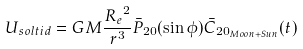<formula> <loc_0><loc_0><loc_500><loc_500>U _ { s o l t i d } = G M \frac { { R _ { e } } ^ { 2 } } { r ^ { 3 } } \bar { P } _ { 2 0 } ( \sin \phi ) \bar { C } _ { { 2 0 } _ { M o o n + S u n } } ( t )</formula> 